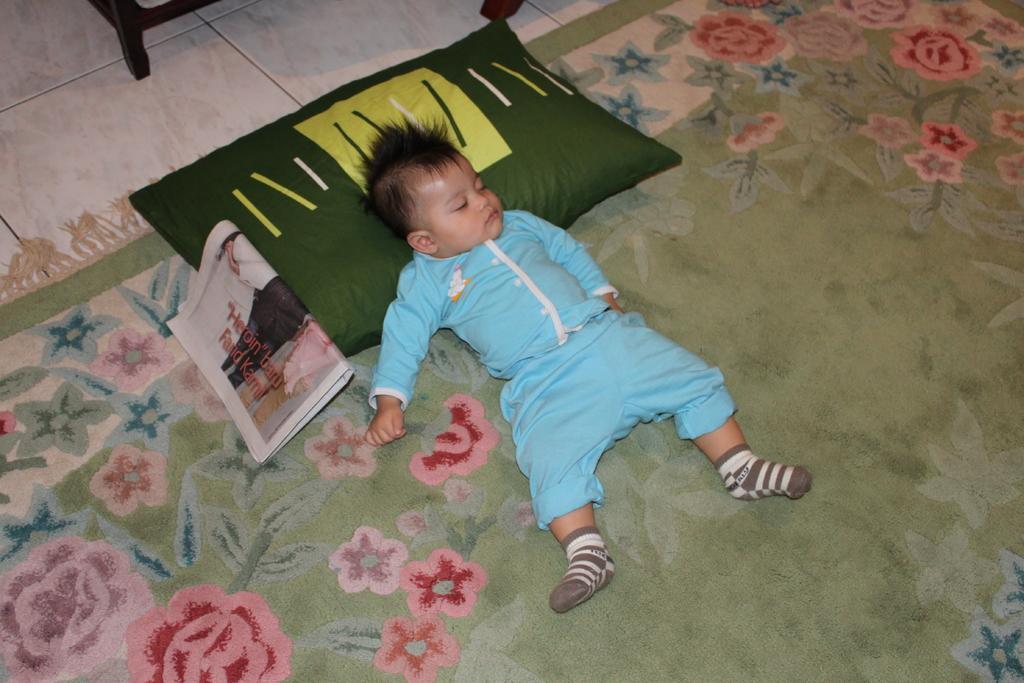Please provide a concise description of this image. In this image we can see a boy is sleeping on the carpet. There is a pillow and newspaper on the carpet. At the top of the image, we can see the floor and a wooden object. 